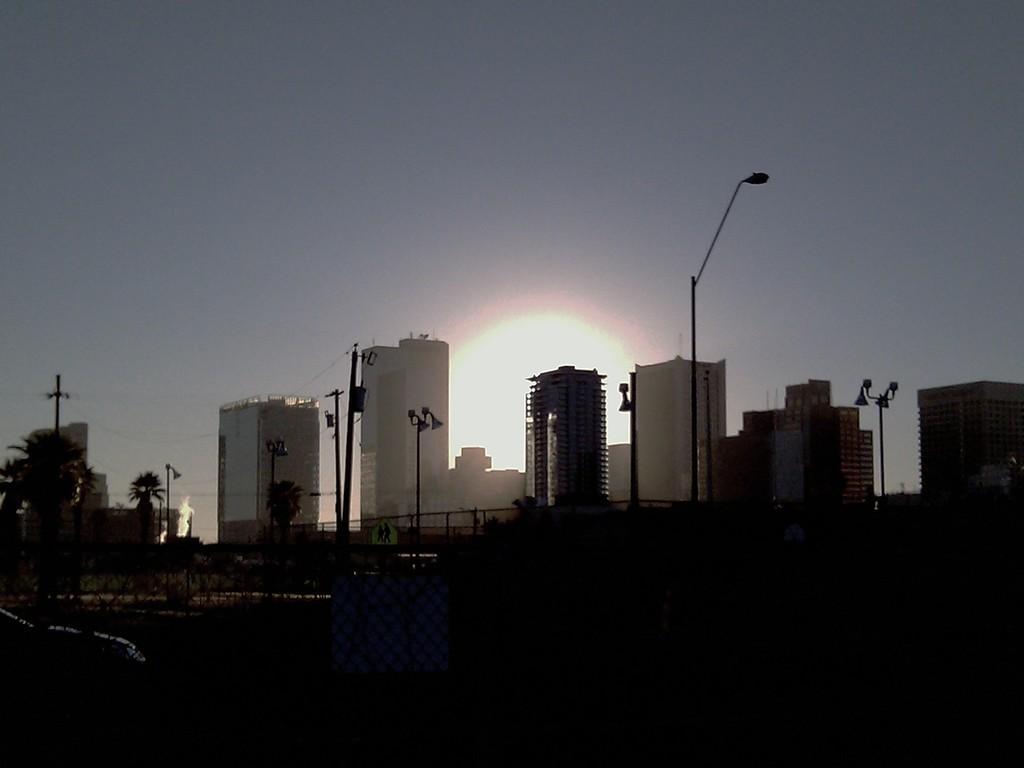Please provide a concise description of this image. In this image we can see trees, poles, and buildings. In the background there is sky. At the bottom of the image it is dark. 